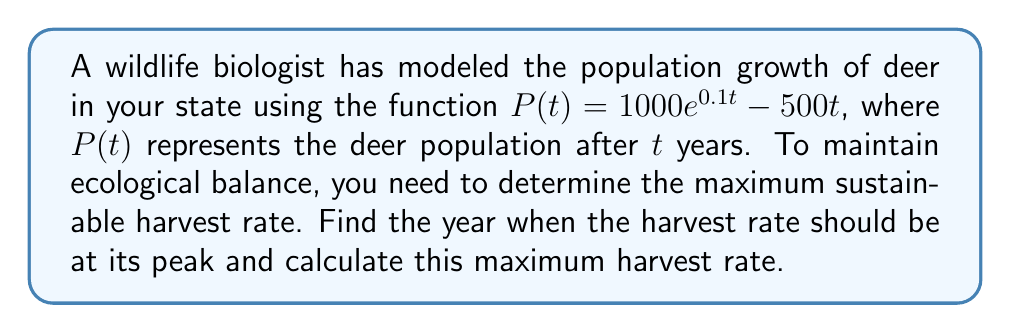Teach me how to tackle this problem. To solve this problem, we need to follow these steps:

1) The harvest rate is represented by the rate of change of the population, which is the derivative of $P(t)$.

2) Let's find $P'(t)$:
   $$P'(t) = 1000 \cdot 0.1e^{0.1t} - 500 = 100e^{0.1t} - 500$$

3) To find the maximum harvest rate, we need to find where $P''(t) = 0$:
   $$P''(t) = 100 \cdot 0.1e^{0.1t} = 10e^{0.1t}$$

4) Setting $P''(t) = 0$:
   $$10e^{0.1t} = 0$$
   This equation has no solution, meaning there's no inflection point.

5) Since $P''(t)$ is always positive, $P'(t)$ is always increasing. The maximum harvest rate will occur at the latest time in our model.

6) Assuming we're looking at a 10-year plan, the maximum harvest rate will occur at $t = 10$.

7) Calculate the maximum harvest rate:
   $$P'(10) = 100e^{0.1 \cdot 10} - 500 = 100e^1 - 500 \approx 1718.28$$

Therefore, the maximum sustainable harvest rate occurs at year 10 and is approximately 1718 deer per year.
Answer: Year 10; 1718 deer/year 